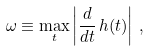Convert formula to latex. <formula><loc_0><loc_0><loc_500><loc_500>\omega \equiv \max _ { t } \left | \frac { d } { d t } \, { h } ( t ) \right | \, ,</formula> 